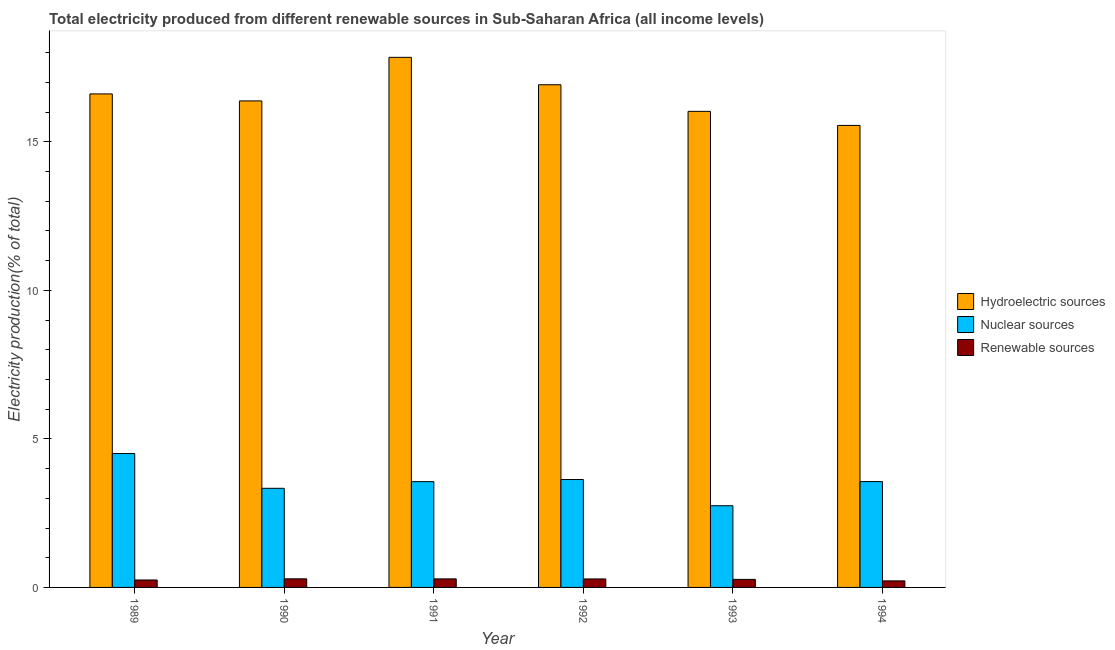How many different coloured bars are there?
Provide a short and direct response. 3. Are the number of bars per tick equal to the number of legend labels?
Your answer should be very brief. Yes. Are the number of bars on each tick of the X-axis equal?
Keep it short and to the point. Yes. What is the label of the 4th group of bars from the left?
Make the answer very short. 1992. What is the percentage of electricity produced by renewable sources in 1990?
Your answer should be compact. 0.29. Across all years, what is the maximum percentage of electricity produced by renewable sources?
Provide a short and direct response. 0.29. Across all years, what is the minimum percentage of electricity produced by nuclear sources?
Ensure brevity in your answer.  2.75. In which year was the percentage of electricity produced by renewable sources maximum?
Provide a succinct answer. 1990. What is the total percentage of electricity produced by nuclear sources in the graph?
Provide a succinct answer. 21.35. What is the difference between the percentage of electricity produced by renewable sources in 1991 and that in 1992?
Provide a short and direct response. 0. What is the difference between the percentage of electricity produced by hydroelectric sources in 1994 and the percentage of electricity produced by renewable sources in 1990?
Your response must be concise. -0.82. What is the average percentage of electricity produced by nuclear sources per year?
Provide a succinct answer. 3.56. In how many years, is the percentage of electricity produced by hydroelectric sources greater than 12 %?
Give a very brief answer. 6. What is the ratio of the percentage of electricity produced by renewable sources in 1989 to that in 1993?
Provide a succinct answer. 0.92. Is the percentage of electricity produced by nuclear sources in 1991 less than that in 1992?
Keep it short and to the point. Yes. What is the difference between the highest and the second highest percentage of electricity produced by nuclear sources?
Give a very brief answer. 0.87. What is the difference between the highest and the lowest percentage of electricity produced by renewable sources?
Your response must be concise. 0.07. In how many years, is the percentage of electricity produced by nuclear sources greater than the average percentage of electricity produced by nuclear sources taken over all years?
Ensure brevity in your answer.  4. What does the 3rd bar from the left in 1991 represents?
Give a very brief answer. Renewable sources. What does the 1st bar from the right in 1993 represents?
Offer a terse response. Renewable sources. Is it the case that in every year, the sum of the percentage of electricity produced by hydroelectric sources and percentage of electricity produced by nuclear sources is greater than the percentage of electricity produced by renewable sources?
Ensure brevity in your answer.  Yes. Are all the bars in the graph horizontal?
Give a very brief answer. No. How many years are there in the graph?
Offer a terse response. 6. What is the difference between two consecutive major ticks on the Y-axis?
Make the answer very short. 5. Are the values on the major ticks of Y-axis written in scientific E-notation?
Give a very brief answer. No. How many legend labels are there?
Give a very brief answer. 3. What is the title of the graph?
Your answer should be very brief. Total electricity produced from different renewable sources in Sub-Saharan Africa (all income levels). Does "Unpaid family workers" appear as one of the legend labels in the graph?
Offer a terse response. No. What is the label or title of the Y-axis?
Ensure brevity in your answer.  Electricity production(% of total). What is the Electricity production(% of total) in Hydroelectric sources in 1989?
Provide a succinct answer. 16.61. What is the Electricity production(% of total) of Nuclear sources in 1989?
Provide a succinct answer. 4.51. What is the Electricity production(% of total) in Renewable sources in 1989?
Make the answer very short. 0.25. What is the Electricity production(% of total) in Hydroelectric sources in 1990?
Make the answer very short. 16.38. What is the Electricity production(% of total) of Nuclear sources in 1990?
Make the answer very short. 3.34. What is the Electricity production(% of total) in Renewable sources in 1990?
Your answer should be very brief. 0.29. What is the Electricity production(% of total) of Hydroelectric sources in 1991?
Offer a terse response. 17.84. What is the Electricity production(% of total) of Nuclear sources in 1991?
Your answer should be compact. 3.56. What is the Electricity production(% of total) of Renewable sources in 1991?
Offer a very short reply. 0.29. What is the Electricity production(% of total) of Hydroelectric sources in 1992?
Offer a very short reply. 16.92. What is the Electricity production(% of total) of Nuclear sources in 1992?
Give a very brief answer. 3.63. What is the Electricity production(% of total) of Renewable sources in 1992?
Offer a very short reply. 0.29. What is the Electricity production(% of total) in Hydroelectric sources in 1993?
Your answer should be very brief. 16.03. What is the Electricity production(% of total) of Nuclear sources in 1993?
Your response must be concise. 2.75. What is the Electricity production(% of total) in Renewable sources in 1993?
Keep it short and to the point. 0.27. What is the Electricity production(% of total) in Hydroelectric sources in 1994?
Ensure brevity in your answer.  15.55. What is the Electricity production(% of total) of Nuclear sources in 1994?
Offer a very short reply. 3.56. What is the Electricity production(% of total) in Renewable sources in 1994?
Keep it short and to the point. 0.22. Across all years, what is the maximum Electricity production(% of total) of Hydroelectric sources?
Make the answer very short. 17.84. Across all years, what is the maximum Electricity production(% of total) in Nuclear sources?
Ensure brevity in your answer.  4.51. Across all years, what is the maximum Electricity production(% of total) of Renewable sources?
Provide a succinct answer. 0.29. Across all years, what is the minimum Electricity production(% of total) of Hydroelectric sources?
Provide a succinct answer. 15.55. Across all years, what is the minimum Electricity production(% of total) of Nuclear sources?
Ensure brevity in your answer.  2.75. Across all years, what is the minimum Electricity production(% of total) in Renewable sources?
Your answer should be very brief. 0.22. What is the total Electricity production(% of total) in Hydroelectric sources in the graph?
Make the answer very short. 99.33. What is the total Electricity production(% of total) in Nuclear sources in the graph?
Provide a short and direct response. 21.35. What is the total Electricity production(% of total) in Renewable sources in the graph?
Your answer should be very brief. 1.6. What is the difference between the Electricity production(% of total) in Hydroelectric sources in 1989 and that in 1990?
Your response must be concise. 0.24. What is the difference between the Electricity production(% of total) of Nuclear sources in 1989 and that in 1990?
Your answer should be very brief. 1.17. What is the difference between the Electricity production(% of total) of Renewable sources in 1989 and that in 1990?
Provide a succinct answer. -0.04. What is the difference between the Electricity production(% of total) of Hydroelectric sources in 1989 and that in 1991?
Offer a terse response. -1.23. What is the difference between the Electricity production(% of total) of Nuclear sources in 1989 and that in 1991?
Provide a succinct answer. 0.95. What is the difference between the Electricity production(% of total) of Renewable sources in 1989 and that in 1991?
Your answer should be compact. -0.04. What is the difference between the Electricity production(% of total) of Hydroelectric sources in 1989 and that in 1992?
Your answer should be compact. -0.31. What is the difference between the Electricity production(% of total) in Nuclear sources in 1989 and that in 1992?
Offer a very short reply. 0.87. What is the difference between the Electricity production(% of total) in Renewable sources in 1989 and that in 1992?
Your response must be concise. -0.03. What is the difference between the Electricity production(% of total) in Hydroelectric sources in 1989 and that in 1993?
Provide a succinct answer. 0.59. What is the difference between the Electricity production(% of total) in Nuclear sources in 1989 and that in 1993?
Ensure brevity in your answer.  1.76. What is the difference between the Electricity production(% of total) of Renewable sources in 1989 and that in 1993?
Your answer should be very brief. -0.02. What is the difference between the Electricity production(% of total) of Hydroelectric sources in 1989 and that in 1994?
Offer a very short reply. 1.06. What is the difference between the Electricity production(% of total) of Nuclear sources in 1989 and that in 1994?
Your response must be concise. 0.94. What is the difference between the Electricity production(% of total) in Renewable sources in 1989 and that in 1994?
Give a very brief answer. 0.03. What is the difference between the Electricity production(% of total) in Hydroelectric sources in 1990 and that in 1991?
Provide a short and direct response. -1.47. What is the difference between the Electricity production(% of total) of Nuclear sources in 1990 and that in 1991?
Keep it short and to the point. -0.22. What is the difference between the Electricity production(% of total) in Renewable sources in 1990 and that in 1991?
Offer a very short reply. 0. What is the difference between the Electricity production(% of total) in Hydroelectric sources in 1990 and that in 1992?
Keep it short and to the point. -0.54. What is the difference between the Electricity production(% of total) in Nuclear sources in 1990 and that in 1992?
Give a very brief answer. -0.3. What is the difference between the Electricity production(% of total) in Renewable sources in 1990 and that in 1992?
Offer a terse response. 0. What is the difference between the Electricity production(% of total) of Hydroelectric sources in 1990 and that in 1993?
Keep it short and to the point. 0.35. What is the difference between the Electricity production(% of total) in Nuclear sources in 1990 and that in 1993?
Offer a terse response. 0.59. What is the difference between the Electricity production(% of total) in Renewable sources in 1990 and that in 1993?
Keep it short and to the point. 0.02. What is the difference between the Electricity production(% of total) of Hydroelectric sources in 1990 and that in 1994?
Give a very brief answer. 0.82. What is the difference between the Electricity production(% of total) of Nuclear sources in 1990 and that in 1994?
Offer a terse response. -0.23. What is the difference between the Electricity production(% of total) of Renewable sources in 1990 and that in 1994?
Your answer should be very brief. 0.07. What is the difference between the Electricity production(% of total) in Hydroelectric sources in 1991 and that in 1992?
Your answer should be very brief. 0.92. What is the difference between the Electricity production(% of total) of Nuclear sources in 1991 and that in 1992?
Provide a short and direct response. -0.07. What is the difference between the Electricity production(% of total) of Renewable sources in 1991 and that in 1992?
Ensure brevity in your answer.  0. What is the difference between the Electricity production(% of total) of Hydroelectric sources in 1991 and that in 1993?
Make the answer very short. 1.82. What is the difference between the Electricity production(% of total) of Nuclear sources in 1991 and that in 1993?
Make the answer very short. 0.81. What is the difference between the Electricity production(% of total) in Renewable sources in 1991 and that in 1993?
Provide a succinct answer. 0.02. What is the difference between the Electricity production(% of total) of Hydroelectric sources in 1991 and that in 1994?
Your answer should be very brief. 2.29. What is the difference between the Electricity production(% of total) in Nuclear sources in 1991 and that in 1994?
Your answer should be very brief. -0. What is the difference between the Electricity production(% of total) in Renewable sources in 1991 and that in 1994?
Offer a terse response. 0.07. What is the difference between the Electricity production(% of total) in Hydroelectric sources in 1992 and that in 1993?
Your answer should be compact. 0.9. What is the difference between the Electricity production(% of total) in Nuclear sources in 1992 and that in 1993?
Your response must be concise. 0.88. What is the difference between the Electricity production(% of total) in Renewable sources in 1992 and that in 1993?
Make the answer very short. 0.01. What is the difference between the Electricity production(% of total) of Hydroelectric sources in 1992 and that in 1994?
Provide a succinct answer. 1.37. What is the difference between the Electricity production(% of total) of Nuclear sources in 1992 and that in 1994?
Your answer should be very brief. 0.07. What is the difference between the Electricity production(% of total) in Renewable sources in 1992 and that in 1994?
Keep it short and to the point. 0.07. What is the difference between the Electricity production(% of total) in Hydroelectric sources in 1993 and that in 1994?
Provide a short and direct response. 0.47. What is the difference between the Electricity production(% of total) of Nuclear sources in 1993 and that in 1994?
Give a very brief answer. -0.81. What is the difference between the Electricity production(% of total) of Renewable sources in 1993 and that in 1994?
Offer a very short reply. 0.05. What is the difference between the Electricity production(% of total) of Hydroelectric sources in 1989 and the Electricity production(% of total) of Nuclear sources in 1990?
Offer a terse response. 13.28. What is the difference between the Electricity production(% of total) of Hydroelectric sources in 1989 and the Electricity production(% of total) of Renewable sources in 1990?
Your response must be concise. 16.32. What is the difference between the Electricity production(% of total) of Nuclear sources in 1989 and the Electricity production(% of total) of Renewable sources in 1990?
Provide a short and direct response. 4.22. What is the difference between the Electricity production(% of total) in Hydroelectric sources in 1989 and the Electricity production(% of total) in Nuclear sources in 1991?
Offer a terse response. 13.05. What is the difference between the Electricity production(% of total) in Hydroelectric sources in 1989 and the Electricity production(% of total) in Renewable sources in 1991?
Offer a terse response. 16.32. What is the difference between the Electricity production(% of total) of Nuclear sources in 1989 and the Electricity production(% of total) of Renewable sources in 1991?
Make the answer very short. 4.22. What is the difference between the Electricity production(% of total) in Hydroelectric sources in 1989 and the Electricity production(% of total) in Nuclear sources in 1992?
Your response must be concise. 12.98. What is the difference between the Electricity production(% of total) in Hydroelectric sources in 1989 and the Electricity production(% of total) in Renewable sources in 1992?
Offer a terse response. 16.33. What is the difference between the Electricity production(% of total) of Nuclear sources in 1989 and the Electricity production(% of total) of Renewable sources in 1992?
Keep it short and to the point. 4.22. What is the difference between the Electricity production(% of total) of Hydroelectric sources in 1989 and the Electricity production(% of total) of Nuclear sources in 1993?
Your answer should be compact. 13.86. What is the difference between the Electricity production(% of total) of Hydroelectric sources in 1989 and the Electricity production(% of total) of Renewable sources in 1993?
Provide a succinct answer. 16.34. What is the difference between the Electricity production(% of total) in Nuclear sources in 1989 and the Electricity production(% of total) in Renewable sources in 1993?
Your answer should be very brief. 4.24. What is the difference between the Electricity production(% of total) in Hydroelectric sources in 1989 and the Electricity production(% of total) in Nuclear sources in 1994?
Your response must be concise. 13.05. What is the difference between the Electricity production(% of total) in Hydroelectric sources in 1989 and the Electricity production(% of total) in Renewable sources in 1994?
Keep it short and to the point. 16.39. What is the difference between the Electricity production(% of total) in Nuclear sources in 1989 and the Electricity production(% of total) in Renewable sources in 1994?
Offer a very short reply. 4.29. What is the difference between the Electricity production(% of total) of Hydroelectric sources in 1990 and the Electricity production(% of total) of Nuclear sources in 1991?
Provide a succinct answer. 12.82. What is the difference between the Electricity production(% of total) in Hydroelectric sources in 1990 and the Electricity production(% of total) in Renewable sources in 1991?
Ensure brevity in your answer.  16.09. What is the difference between the Electricity production(% of total) of Nuclear sources in 1990 and the Electricity production(% of total) of Renewable sources in 1991?
Offer a very short reply. 3.05. What is the difference between the Electricity production(% of total) in Hydroelectric sources in 1990 and the Electricity production(% of total) in Nuclear sources in 1992?
Ensure brevity in your answer.  12.74. What is the difference between the Electricity production(% of total) in Hydroelectric sources in 1990 and the Electricity production(% of total) in Renewable sources in 1992?
Offer a very short reply. 16.09. What is the difference between the Electricity production(% of total) in Nuclear sources in 1990 and the Electricity production(% of total) in Renewable sources in 1992?
Your response must be concise. 3.05. What is the difference between the Electricity production(% of total) in Hydroelectric sources in 1990 and the Electricity production(% of total) in Nuclear sources in 1993?
Keep it short and to the point. 13.63. What is the difference between the Electricity production(% of total) in Hydroelectric sources in 1990 and the Electricity production(% of total) in Renewable sources in 1993?
Ensure brevity in your answer.  16.11. What is the difference between the Electricity production(% of total) of Nuclear sources in 1990 and the Electricity production(% of total) of Renewable sources in 1993?
Keep it short and to the point. 3.07. What is the difference between the Electricity production(% of total) in Hydroelectric sources in 1990 and the Electricity production(% of total) in Nuclear sources in 1994?
Offer a very short reply. 12.81. What is the difference between the Electricity production(% of total) of Hydroelectric sources in 1990 and the Electricity production(% of total) of Renewable sources in 1994?
Your answer should be compact. 16.16. What is the difference between the Electricity production(% of total) of Nuclear sources in 1990 and the Electricity production(% of total) of Renewable sources in 1994?
Offer a very short reply. 3.12. What is the difference between the Electricity production(% of total) in Hydroelectric sources in 1991 and the Electricity production(% of total) in Nuclear sources in 1992?
Give a very brief answer. 14.21. What is the difference between the Electricity production(% of total) of Hydroelectric sources in 1991 and the Electricity production(% of total) of Renewable sources in 1992?
Your answer should be very brief. 17.56. What is the difference between the Electricity production(% of total) of Nuclear sources in 1991 and the Electricity production(% of total) of Renewable sources in 1992?
Keep it short and to the point. 3.27. What is the difference between the Electricity production(% of total) of Hydroelectric sources in 1991 and the Electricity production(% of total) of Nuclear sources in 1993?
Offer a terse response. 15.09. What is the difference between the Electricity production(% of total) in Hydroelectric sources in 1991 and the Electricity production(% of total) in Renewable sources in 1993?
Provide a short and direct response. 17.57. What is the difference between the Electricity production(% of total) in Nuclear sources in 1991 and the Electricity production(% of total) in Renewable sources in 1993?
Ensure brevity in your answer.  3.29. What is the difference between the Electricity production(% of total) of Hydroelectric sources in 1991 and the Electricity production(% of total) of Nuclear sources in 1994?
Your answer should be very brief. 14.28. What is the difference between the Electricity production(% of total) of Hydroelectric sources in 1991 and the Electricity production(% of total) of Renewable sources in 1994?
Offer a terse response. 17.62. What is the difference between the Electricity production(% of total) in Nuclear sources in 1991 and the Electricity production(% of total) in Renewable sources in 1994?
Provide a short and direct response. 3.34. What is the difference between the Electricity production(% of total) in Hydroelectric sources in 1992 and the Electricity production(% of total) in Nuclear sources in 1993?
Offer a very short reply. 14.17. What is the difference between the Electricity production(% of total) of Hydroelectric sources in 1992 and the Electricity production(% of total) of Renewable sources in 1993?
Give a very brief answer. 16.65. What is the difference between the Electricity production(% of total) of Nuclear sources in 1992 and the Electricity production(% of total) of Renewable sources in 1993?
Provide a short and direct response. 3.36. What is the difference between the Electricity production(% of total) of Hydroelectric sources in 1992 and the Electricity production(% of total) of Nuclear sources in 1994?
Make the answer very short. 13.36. What is the difference between the Electricity production(% of total) of Hydroelectric sources in 1992 and the Electricity production(% of total) of Renewable sources in 1994?
Provide a short and direct response. 16.7. What is the difference between the Electricity production(% of total) in Nuclear sources in 1992 and the Electricity production(% of total) in Renewable sources in 1994?
Your answer should be compact. 3.41. What is the difference between the Electricity production(% of total) in Hydroelectric sources in 1993 and the Electricity production(% of total) in Nuclear sources in 1994?
Provide a succinct answer. 12.46. What is the difference between the Electricity production(% of total) of Hydroelectric sources in 1993 and the Electricity production(% of total) of Renewable sources in 1994?
Offer a very short reply. 15.8. What is the difference between the Electricity production(% of total) in Nuclear sources in 1993 and the Electricity production(% of total) in Renewable sources in 1994?
Provide a succinct answer. 2.53. What is the average Electricity production(% of total) in Hydroelectric sources per year?
Provide a succinct answer. 16.56. What is the average Electricity production(% of total) in Nuclear sources per year?
Offer a very short reply. 3.56. What is the average Electricity production(% of total) in Renewable sources per year?
Your answer should be compact. 0.27. In the year 1989, what is the difference between the Electricity production(% of total) in Hydroelectric sources and Electricity production(% of total) in Nuclear sources?
Your response must be concise. 12.11. In the year 1989, what is the difference between the Electricity production(% of total) of Hydroelectric sources and Electricity production(% of total) of Renewable sources?
Your answer should be very brief. 16.36. In the year 1989, what is the difference between the Electricity production(% of total) of Nuclear sources and Electricity production(% of total) of Renewable sources?
Ensure brevity in your answer.  4.26. In the year 1990, what is the difference between the Electricity production(% of total) in Hydroelectric sources and Electricity production(% of total) in Nuclear sources?
Make the answer very short. 13.04. In the year 1990, what is the difference between the Electricity production(% of total) in Hydroelectric sources and Electricity production(% of total) in Renewable sources?
Give a very brief answer. 16.09. In the year 1990, what is the difference between the Electricity production(% of total) of Nuclear sources and Electricity production(% of total) of Renewable sources?
Provide a short and direct response. 3.05. In the year 1991, what is the difference between the Electricity production(% of total) of Hydroelectric sources and Electricity production(% of total) of Nuclear sources?
Offer a terse response. 14.28. In the year 1991, what is the difference between the Electricity production(% of total) in Hydroelectric sources and Electricity production(% of total) in Renewable sources?
Keep it short and to the point. 17.56. In the year 1991, what is the difference between the Electricity production(% of total) in Nuclear sources and Electricity production(% of total) in Renewable sources?
Offer a terse response. 3.27. In the year 1992, what is the difference between the Electricity production(% of total) of Hydroelectric sources and Electricity production(% of total) of Nuclear sources?
Make the answer very short. 13.29. In the year 1992, what is the difference between the Electricity production(% of total) of Hydroelectric sources and Electricity production(% of total) of Renewable sources?
Offer a terse response. 16.64. In the year 1992, what is the difference between the Electricity production(% of total) of Nuclear sources and Electricity production(% of total) of Renewable sources?
Offer a terse response. 3.35. In the year 1993, what is the difference between the Electricity production(% of total) in Hydroelectric sources and Electricity production(% of total) in Nuclear sources?
Ensure brevity in your answer.  13.28. In the year 1993, what is the difference between the Electricity production(% of total) in Hydroelectric sources and Electricity production(% of total) in Renewable sources?
Your answer should be very brief. 15.75. In the year 1993, what is the difference between the Electricity production(% of total) in Nuclear sources and Electricity production(% of total) in Renewable sources?
Give a very brief answer. 2.48. In the year 1994, what is the difference between the Electricity production(% of total) in Hydroelectric sources and Electricity production(% of total) in Nuclear sources?
Offer a very short reply. 11.99. In the year 1994, what is the difference between the Electricity production(% of total) in Hydroelectric sources and Electricity production(% of total) in Renewable sources?
Offer a very short reply. 15.33. In the year 1994, what is the difference between the Electricity production(% of total) of Nuclear sources and Electricity production(% of total) of Renewable sources?
Give a very brief answer. 3.34. What is the ratio of the Electricity production(% of total) of Hydroelectric sources in 1989 to that in 1990?
Keep it short and to the point. 1.01. What is the ratio of the Electricity production(% of total) of Nuclear sources in 1989 to that in 1990?
Ensure brevity in your answer.  1.35. What is the ratio of the Electricity production(% of total) of Renewable sources in 1989 to that in 1990?
Your answer should be compact. 0.87. What is the ratio of the Electricity production(% of total) of Nuclear sources in 1989 to that in 1991?
Your response must be concise. 1.27. What is the ratio of the Electricity production(% of total) in Renewable sources in 1989 to that in 1991?
Your answer should be compact. 0.87. What is the ratio of the Electricity production(% of total) in Hydroelectric sources in 1989 to that in 1992?
Offer a terse response. 0.98. What is the ratio of the Electricity production(% of total) in Nuclear sources in 1989 to that in 1992?
Your response must be concise. 1.24. What is the ratio of the Electricity production(% of total) in Renewable sources in 1989 to that in 1992?
Keep it short and to the point. 0.88. What is the ratio of the Electricity production(% of total) of Hydroelectric sources in 1989 to that in 1993?
Provide a short and direct response. 1.04. What is the ratio of the Electricity production(% of total) of Nuclear sources in 1989 to that in 1993?
Give a very brief answer. 1.64. What is the ratio of the Electricity production(% of total) of Renewable sources in 1989 to that in 1993?
Keep it short and to the point. 0.92. What is the ratio of the Electricity production(% of total) in Hydroelectric sources in 1989 to that in 1994?
Offer a terse response. 1.07. What is the ratio of the Electricity production(% of total) of Nuclear sources in 1989 to that in 1994?
Offer a terse response. 1.26. What is the ratio of the Electricity production(% of total) in Renewable sources in 1989 to that in 1994?
Offer a very short reply. 1.14. What is the ratio of the Electricity production(% of total) of Hydroelectric sources in 1990 to that in 1991?
Provide a short and direct response. 0.92. What is the ratio of the Electricity production(% of total) of Nuclear sources in 1990 to that in 1991?
Offer a terse response. 0.94. What is the ratio of the Electricity production(% of total) of Renewable sources in 1990 to that in 1991?
Provide a succinct answer. 1.01. What is the ratio of the Electricity production(% of total) of Hydroelectric sources in 1990 to that in 1992?
Make the answer very short. 0.97. What is the ratio of the Electricity production(% of total) of Nuclear sources in 1990 to that in 1992?
Give a very brief answer. 0.92. What is the ratio of the Electricity production(% of total) of Renewable sources in 1990 to that in 1992?
Offer a terse response. 1.01. What is the ratio of the Electricity production(% of total) in Hydroelectric sources in 1990 to that in 1993?
Your answer should be compact. 1.02. What is the ratio of the Electricity production(% of total) in Nuclear sources in 1990 to that in 1993?
Provide a succinct answer. 1.21. What is the ratio of the Electricity production(% of total) in Renewable sources in 1990 to that in 1993?
Your response must be concise. 1.07. What is the ratio of the Electricity production(% of total) of Hydroelectric sources in 1990 to that in 1994?
Your response must be concise. 1.05. What is the ratio of the Electricity production(% of total) in Nuclear sources in 1990 to that in 1994?
Your answer should be compact. 0.94. What is the ratio of the Electricity production(% of total) in Renewable sources in 1990 to that in 1994?
Provide a succinct answer. 1.31. What is the ratio of the Electricity production(% of total) in Hydroelectric sources in 1991 to that in 1992?
Your answer should be compact. 1.05. What is the ratio of the Electricity production(% of total) of Nuclear sources in 1991 to that in 1992?
Your answer should be compact. 0.98. What is the ratio of the Electricity production(% of total) in Hydroelectric sources in 1991 to that in 1993?
Your answer should be very brief. 1.11. What is the ratio of the Electricity production(% of total) of Nuclear sources in 1991 to that in 1993?
Provide a short and direct response. 1.29. What is the ratio of the Electricity production(% of total) of Renewable sources in 1991 to that in 1993?
Keep it short and to the point. 1.06. What is the ratio of the Electricity production(% of total) of Hydroelectric sources in 1991 to that in 1994?
Your answer should be very brief. 1.15. What is the ratio of the Electricity production(% of total) of Renewable sources in 1991 to that in 1994?
Make the answer very short. 1.3. What is the ratio of the Electricity production(% of total) of Hydroelectric sources in 1992 to that in 1993?
Your response must be concise. 1.06. What is the ratio of the Electricity production(% of total) in Nuclear sources in 1992 to that in 1993?
Offer a very short reply. 1.32. What is the ratio of the Electricity production(% of total) in Renewable sources in 1992 to that in 1993?
Provide a short and direct response. 1.05. What is the ratio of the Electricity production(% of total) of Hydroelectric sources in 1992 to that in 1994?
Offer a terse response. 1.09. What is the ratio of the Electricity production(% of total) in Nuclear sources in 1992 to that in 1994?
Offer a very short reply. 1.02. What is the ratio of the Electricity production(% of total) of Renewable sources in 1992 to that in 1994?
Provide a succinct answer. 1.29. What is the ratio of the Electricity production(% of total) in Hydroelectric sources in 1993 to that in 1994?
Give a very brief answer. 1.03. What is the ratio of the Electricity production(% of total) of Nuclear sources in 1993 to that in 1994?
Ensure brevity in your answer.  0.77. What is the ratio of the Electricity production(% of total) of Renewable sources in 1993 to that in 1994?
Keep it short and to the point. 1.23. What is the difference between the highest and the second highest Electricity production(% of total) of Hydroelectric sources?
Your answer should be compact. 0.92. What is the difference between the highest and the second highest Electricity production(% of total) of Nuclear sources?
Provide a succinct answer. 0.87. What is the difference between the highest and the second highest Electricity production(% of total) in Renewable sources?
Give a very brief answer. 0. What is the difference between the highest and the lowest Electricity production(% of total) in Hydroelectric sources?
Provide a succinct answer. 2.29. What is the difference between the highest and the lowest Electricity production(% of total) of Nuclear sources?
Provide a short and direct response. 1.76. What is the difference between the highest and the lowest Electricity production(% of total) of Renewable sources?
Provide a short and direct response. 0.07. 